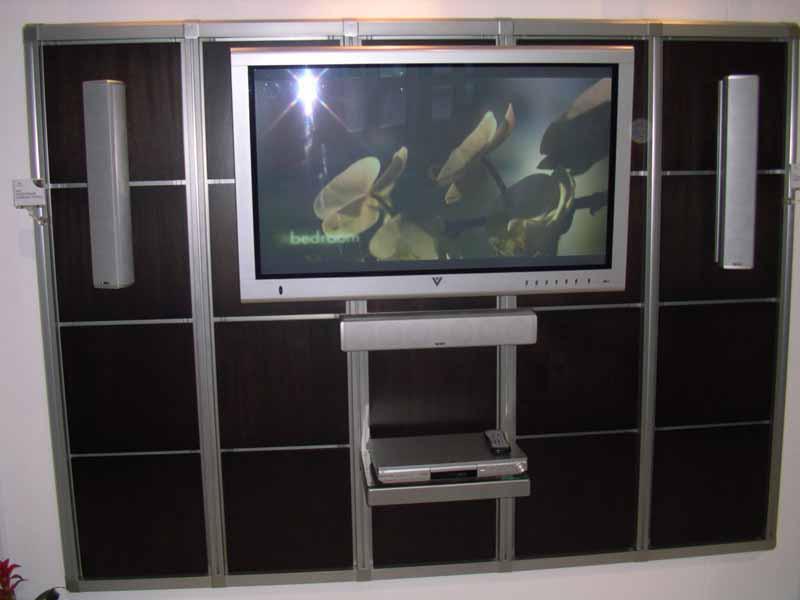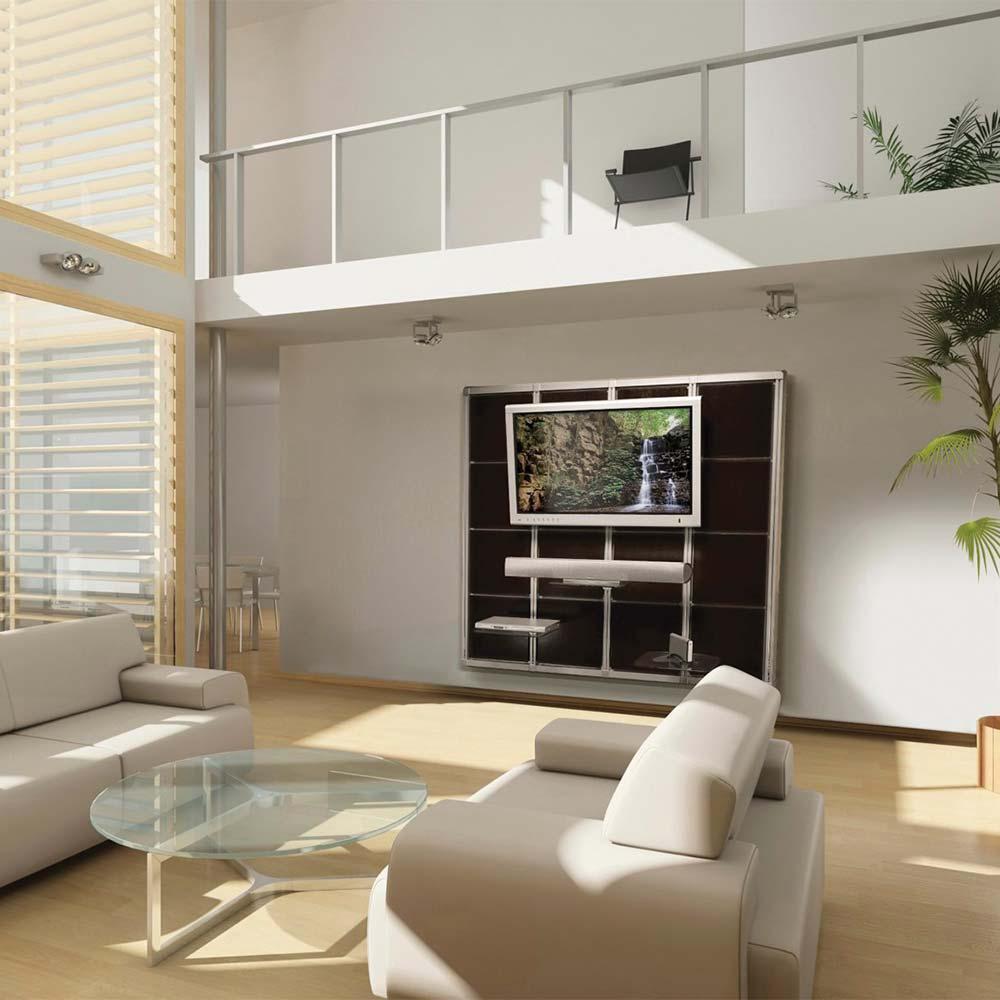The first image is the image on the left, the second image is the image on the right. Evaluate the accuracy of this statement regarding the images: "At least one image has plants.". Is it true? Answer yes or no. Yes. The first image is the image on the left, the second image is the image on the right. Considering the images on both sides, is "Atleast one picture contains a white sofa" valid? Answer yes or no. Yes. 